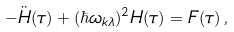Convert formula to latex. <formula><loc_0><loc_0><loc_500><loc_500>- { \ddot { H } } ( \tau ) + ( \hbar { \omega } _ { { k } \lambda } ) ^ { 2 } H ( \tau ) = F ( \tau ) \, ,</formula> 